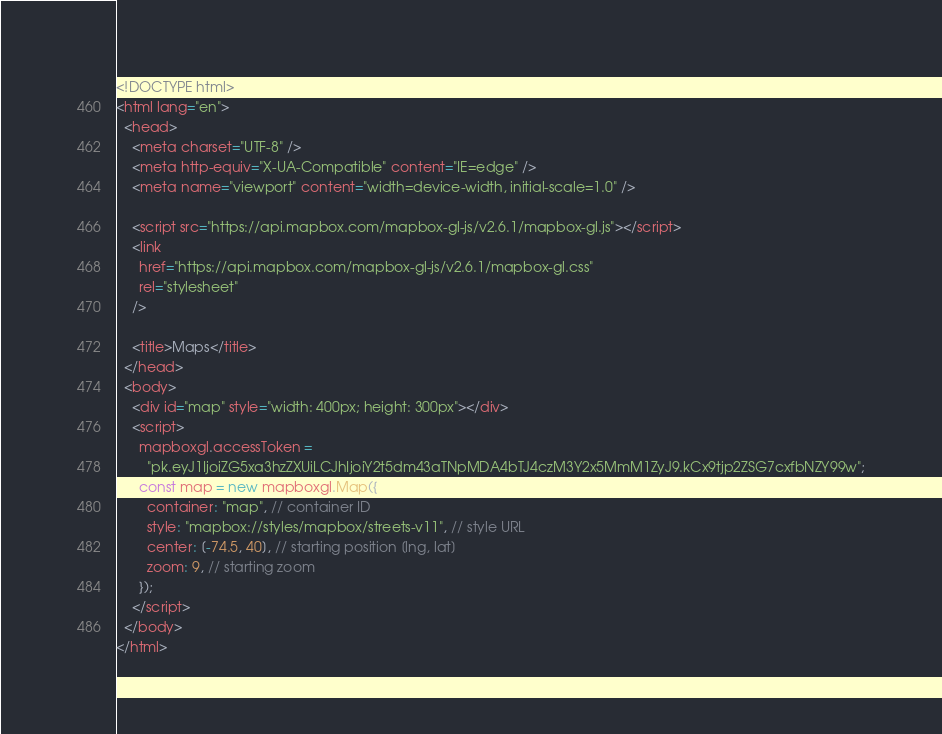<code> <loc_0><loc_0><loc_500><loc_500><_HTML_><!DOCTYPE html>
<html lang="en">
  <head>
    <meta charset="UTF-8" />
    <meta http-equiv="X-UA-Compatible" content="IE=edge" />
    <meta name="viewport" content="width=device-width, initial-scale=1.0" />

    <script src="https://api.mapbox.com/mapbox-gl-js/v2.6.1/mapbox-gl.js"></script>
    <link
      href="https://api.mapbox.com/mapbox-gl-js/v2.6.1/mapbox-gl.css"
      rel="stylesheet"
    />

    <title>Maps</title>
  </head>
  <body>
    <div id="map" style="width: 400px; height: 300px"></div>
    <script>
      mapboxgl.accessToken =
        "pk.eyJ1IjoiZG5xa3hzZXUiLCJhIjoiY2t5dm43aTNpMDA4bTJ4czM3Y2x5MmM1ZyJ9.kCx9tjp2ZSG7cxfbNZY99w";
      const map = new mapboxgl.Map({
        container: "map", // container ID
        style: "mapbox://styles/mapbox/streets-v11", // style URL
        center: [-74.5, 40], // starting position [lng, lat]
        zoom: 9, // starting zoom
      });
    </script>
  </body>
</html>
</code> 